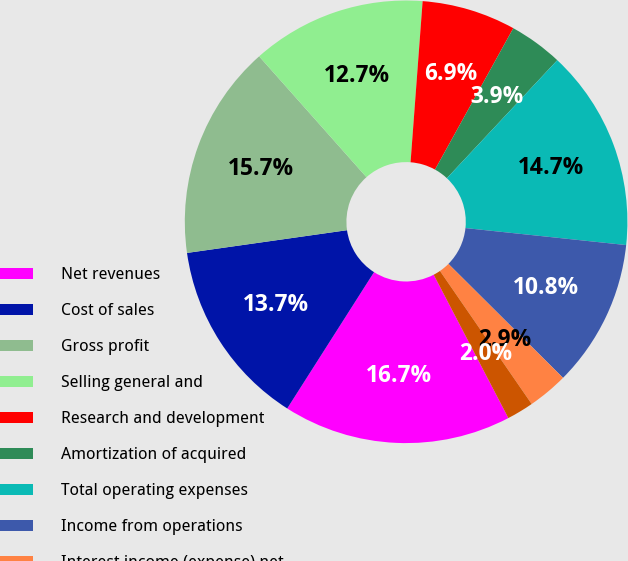Convert chart to OTSL. <chart><loc_0><loc_0><loc_500><loc_500><pie_chart><fcel>Net revenues<fcel>Cost of sales<fcel>Gross profit<fcel>Selling general and<fcel>Research and development<fcel>Amortization of acquired<fcel>Total operating expenses<fcel>Income from operations<fcel>Interest income (expense) net<fcel>Other net (note 13)<nl><fcel>16.67%<fcel>13.73%<fcel>15.69%<fcel>12.75%<fcel>6.86%<fcel>3.92%<fcel>14.71%<fcel>10.78%<fcel>2.94%<fcel>1.96%<nl></chart> 